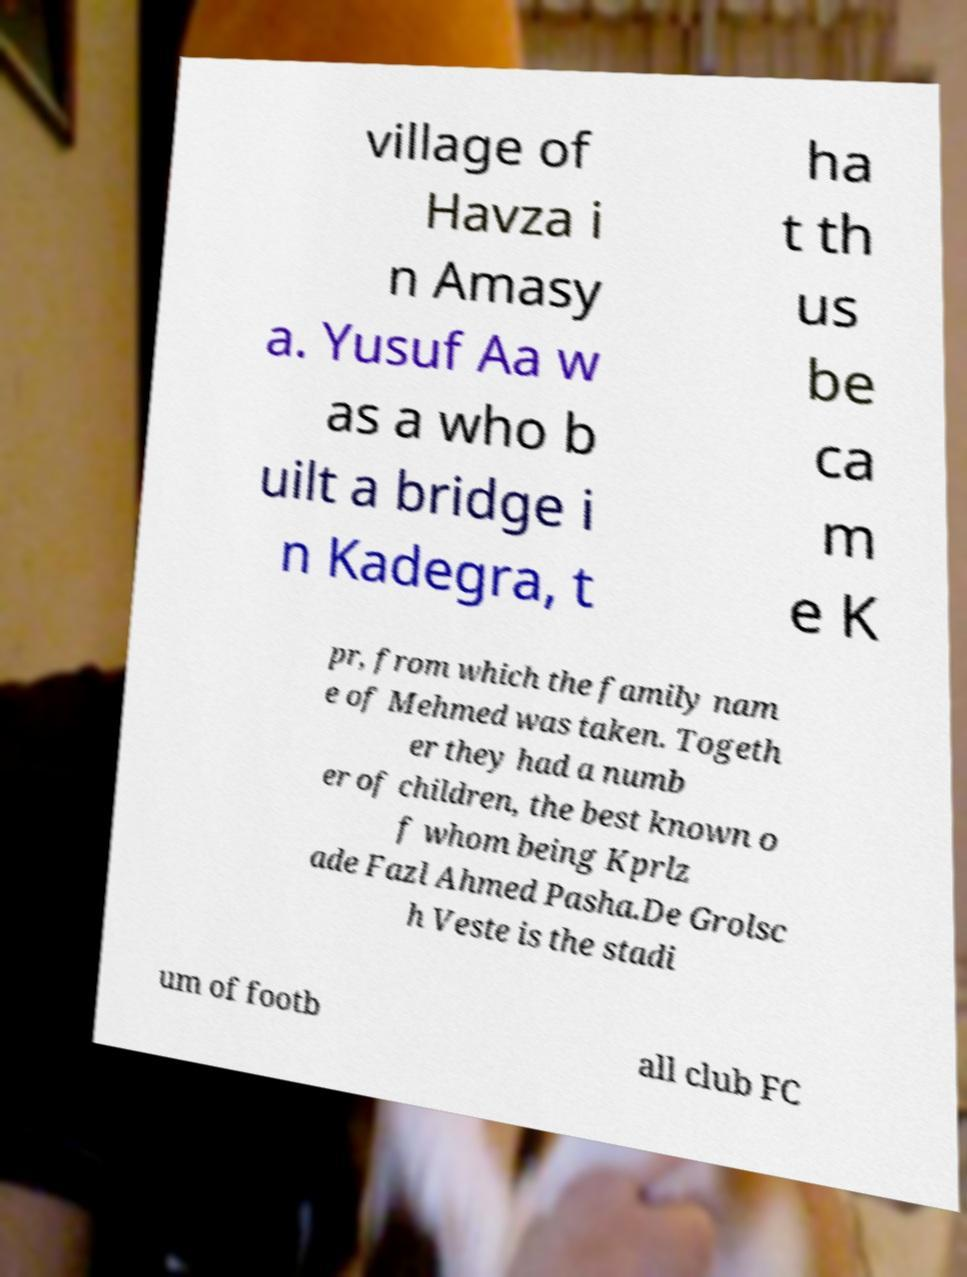Could you assist in decoding the text presented in this image and type it out clearly? village of Havza i n Amasy a. Yusuf Aa w as a who b uilt a bridge i n Kadegra, t ha t th us be ca m e K pr, from which the family nam e of Mehmed was taken. Togeth er they had a numb er of children, the best known o f whom being Kprlz ade Fazl Ahmed Pasha.De Grolsc h Veste is the stadi um of footb all club FC 